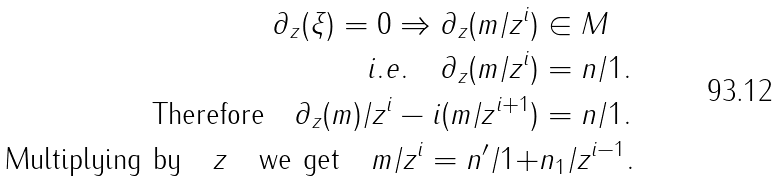Convert formula to latex. <formula><loc_0><loc_0><loc_500><loc_500>\partial _ { z } ( \xi ) = 0 \Rightarrow \partial _ { z } ( m / z ^ { i } ) & \in M \\ i . e . \quad \partial _ { z } ( m / z ^ { i } ) & = n / 1 . \\ \text { Therefore} \quad \partial _ { z } ( m ) / z ^ { i } - i ( m / z ^ { i + 1 } ) & = n / 1 . \\ \text { Multiplying by} \quad z \quad \text {we get} \quad m / z ^ { i } = n ^ { \prime } / 1 + & n _ { 1 } / z ^ { i - 1 } .</formula> 